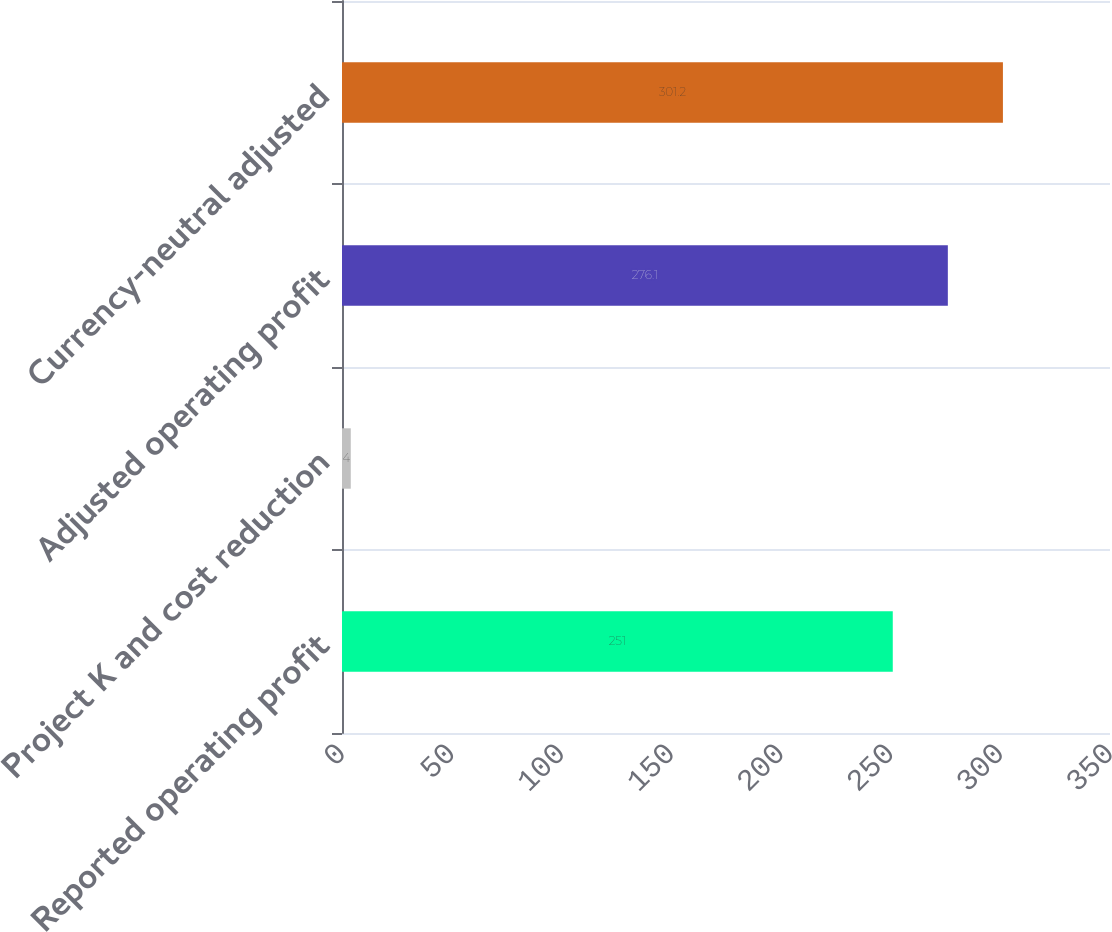Convert chart. <chart><loc_0><loc_0><loc_500><loc_500><bar_chart><fcel>Reported operating profit<fcel>Project K and cost reduction<fcel>Adjusted operating profit<fcel>Currency-neutral adjusted<nl><fcel>251<fcel>4<fcel>276.1<fcel>301.2<nl></chart> 